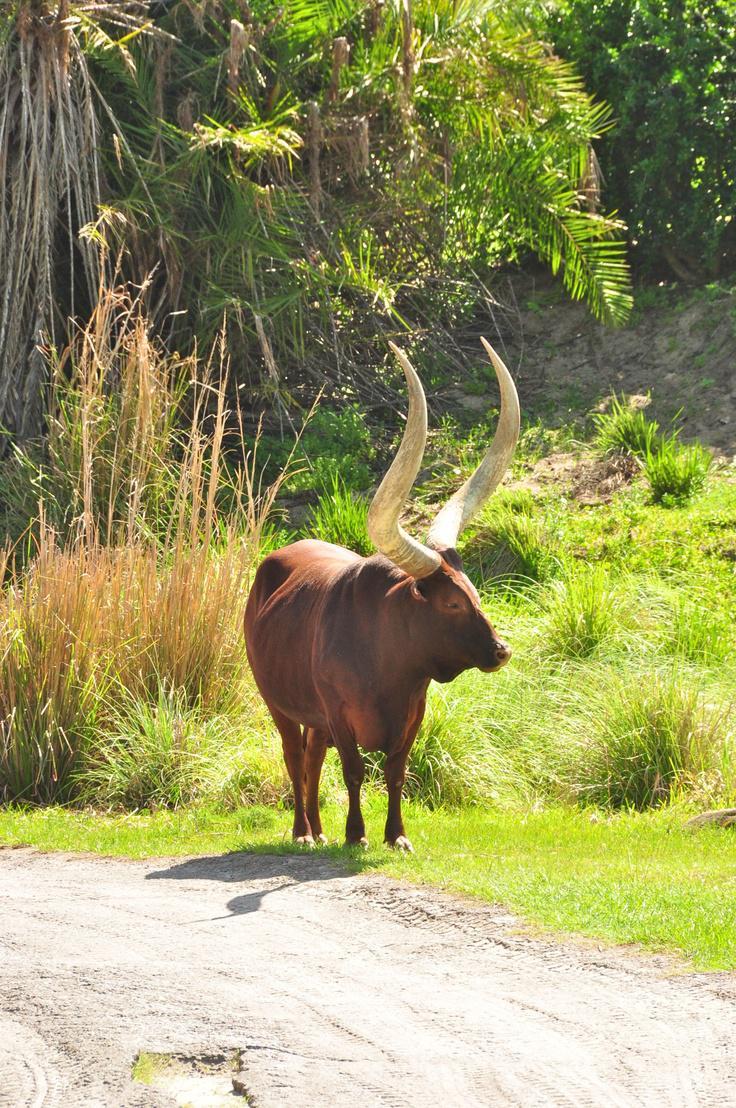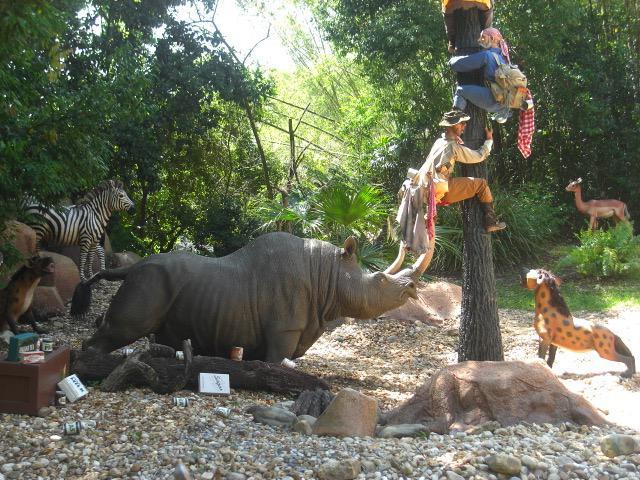The first image is the image on the left, the second image is the image on the right. Given the left and right images, does the statement "There are exactly two animals in the image on the left." hold true? Answer yes or no. No. 